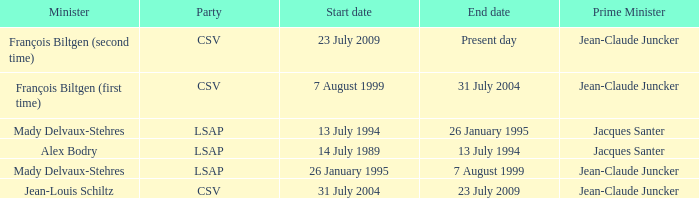Who was the minister for the CSV party with a present day end date? François Biltgen (second time). 